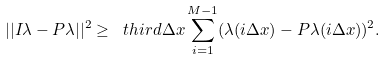<formula> <loc_0><loc_0><loc_500><loc_500>| | I \lambda - P \lambda | | ^ { 2 } \geq \ t h i r d \Delta x \sum _ { i = 1 } ^ { M - 1 } ( \lambda ( i \Delta x ) - P \lambda ( i \Delta x ) ) ^ { 2 } .</formula> 